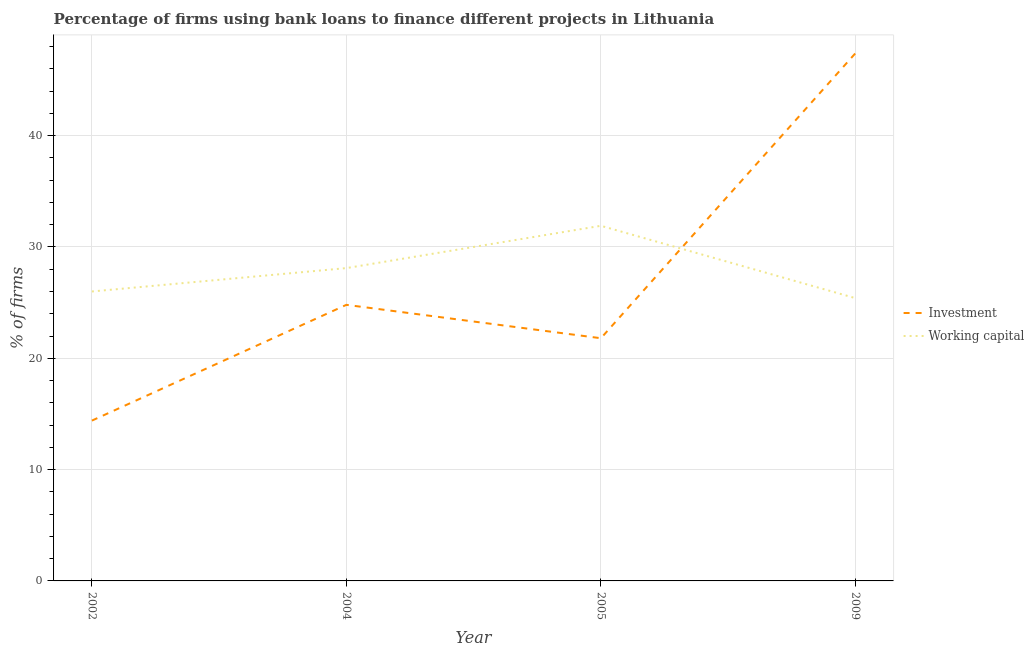How many different coloured lines are there?
Keep it short and to the point. 2. Does the line corresponding to percentage of firms using banks to finance investment intersect with the line corresponding to percentage of firms using banks to finance working capital?
Provide a short and direct response. Yes. Is the number of lines equal to the number of legend labels?
Your answer should be compact. Yes. What is the percentage of firms using banks to finance investment in 2009?
Your response must be concise. 47.4. Across all years, what is the maximum percentage of firms using banks to finance investment?
Provide a succinct answer. 47.4. Across all years, what is the minimum percentage of firms using banks to finance working capital?
Provide a short and direct response. 25.4. In which year was the percentage of firms using banks to finance working capital maximum?
Provide a short and direct response. 2005. In which year was the percentage of firms using banks to finance investment minimum?
Ensure brevity in your answer.  2002. What is the total percentage of firms using banks to finance working capital in the graph?
Provide a succinct answer. 111.4. What is the difference between the percentage of firms using banks to finance investment in 2002 and that in 2009?
Give a very brief answer. -33. What is the difference between the percentage of firms using banks to finance investment in 2009 and the percentage of firms using banks to finance working capital in 2004?
Keep it short and to the point. 19.3. What is the average percentage of firms using banks to finance investment per year?
Provide a short and direct response. 27.1. In the year 2005, what is the difference between the percentage of firms using banks to finance working capital and percentage of firms using banks to finance investment?
Offer a terse response. 10.1. In how many years, is the percentage of firms using banks to finance working capital greater than 18 %?
Ensure brevity in your answer.  4. What is the ratio of the percentage of firms using banks to finance working capital in 2004 to that in 2009?
Give a very brief answer. 1.11. Is the percentage of firms using banks to finance investment in 2002 less than that in 2004?
Keep it short and to the point. Yes. What is the difference between the highest and the second highest percentage of firms using banks to finance investment?
Offer a terse response. 22.6. In how many years, is the percentage of firms using banks to finance working capital greater than the average percentage of firms using banks to finance working capital taken over all years?
Provide a short and direct response. 2. Is the sum of the percentage of firms using banks to finance working capital in 2002 and 2009 greater than the maximum percentage of firms using banks to finance investment across all years?
Offer a very short reply. Yes. Does the percentage of firms using banks to finance investment monotonically increase over the years?
Ensure brevity in your answer.  No. How many years are there in the graph?
Give a very brief answer. 4. Are the values on the major ticks of Y-axis written in scientific E-notation?
Make the answer very short. No. Does the graph contain grids?
Make the answer very short. Yes. Where does the legend appear in the graph?
Ensure brevity in your answer.  Center right. How many legend labels are there?
Your response must be concise. 2. What is the title of the graph?
Your response must be concise. Percentage of firms using bank loans to finance different projects in Lithuania. Does "% of GNI" appear as one of the legend labels in the graph?
Provide a succinct answer. No. What is the label or title of the Y-axis?
Keep it short and to the point. % of firms. What is the % of firms of Investment in 2002?
Offer a terse response. 14.4. What is the % of firms in Working capital in 2002?
Your response must be concise. 26. What is the % of firms in Investment in 2004?
Your response must be concise. 24.8. What is the % of firms in Working capital in 2004?
Give a very brief answer. 28.1. What is the % of firms of Investment in 2005?
Give a very brief answer. 21.8. What is the % of firms in Working capital in 2005?
Make the answer very short. 31.9. What is the % of firms of Investment in 2009?
Ensure brevity in your answer.  47.4. What is the % of firms in Working capital in 2009?
Make the answer very short. 25.4. Across all years, what is the maximum % of firms in Investment?
Provide a short and direct response. 47.4. Across all years, what is the maximum % of firms of Working capital?
Offer a very short reply. 31.9. Across all years, what is the minimum % of firms of Investment?
Give a very brief answer. 14.4. Across all years, what is the minimum % of firms in Working capital?
Offer a very short reply. 25.4. What is the total % of firms in Investment in the graph?
Offer a very short reply. 108.4. What is the total % of firms in Working capital in the graph?
Keep it short and to the point. 111.4. What is the difference between the % of firms in Investment in 2002 and that in 2005?
Offer a terse response. -7.4. What is the difference between the % of firms in Investment in 2002 and that in 2009?
Give a very brief answer. -33. What is the difference between the % of firms in Working capital in 2002 and that in 2009?
Make the answer very short. 0.6. What is the difference between the % of firms in Investment in 2004 and that in 2005?
Give a very brief answer. 3. What is the difference between the % of firms in Investment in 2004 and that in 2009?
Keep it short and to the point. -22.6. What is the difference between the % of firms in Investment in 2005 and that in 2009?
Give a very brief answer. -25.6. What is the difference between the % of firms in Investment in 2002 and the % of firms in Working capital in 2004?
Provide a short and direct response. -13.7. What is the difference between the % of firms of Investment in 2002 and the % of firms of Working capital in 2005?
Offer a very short reply. -17.5. What is the difference between the % of firms in Investment in 2002 and the % of firms in Working capital in 2009?
Provide a short and direct response. -11. What is the difference between the % of firms in Investment in 2004 and the % of firms in Working capital in 2009?
Provide a succinct answer. -0.6. What is the difference between the % of firms of Investment in 2005 and the % of firms of Working capital in 2009?
Offer a very short reply. -3.6. What is the average % of firms of Investment per year?
Make the answer very short. 27.1. What is the average % of firms of Working capital per year?
Provide a short and direct response. 27.85. In the year 2009, what is the difference between the % of firms in Investment and % of firms in Working capital?
Keep it short and to the point. 22. What is the ratio of the % of firms in Investment in 2002 to that in 2004?
Offer a terse response. 0.58. What is the ratio of the % of firms of Working capital in 2002 to that in 2004?
Your answer should be compact. 0.93. What is the ratio of the % of firms of Investment in 2002 to that in 2005?
Your response must be concise. 0.66. What is the ratio of the % of firms of Working capital in 2002 to that in 2005?
Give a very brief answer. 0.81. What is the ratio of the % of firms of Investment in 2002 to that in 2009?
Your answer should be compact. 0.3. What is the ratio of the % of firms of Working capital in 2002 to that in 2009?
Your answer should be very brief. 1.02. What is the ratio of the % of firms of Investment in 2004 to that in 2005?
Your answer should be compact. 1.14. What is the ratio of the % of firms of Working capital in 2004 to that in 2005?
Offer a very short reply. 0.88. What is the ratio of the % of firms of Investment in 2004 to that in 2009?
Provide a succinct answer. 0.52. What is the ratio of the % of firms of Working capital in 2004 to that in 2009?
Your response must be concise. 1.11. What is the ratio of the % of firms of Investment in 2005 to that in 2009?
Offer a very short reply. 0.46. What is the ratio of the % of firms of Working capital in 2005 to that in 2009?
Your response must be concise. 1.26. What is the difference between the highest and the second highest % of firms of Investment?
Make the answer very short. 22.6. What is the difference between the highest and the second highest % of firms of Working capital?
Your answer should be very brief. 3.8. 